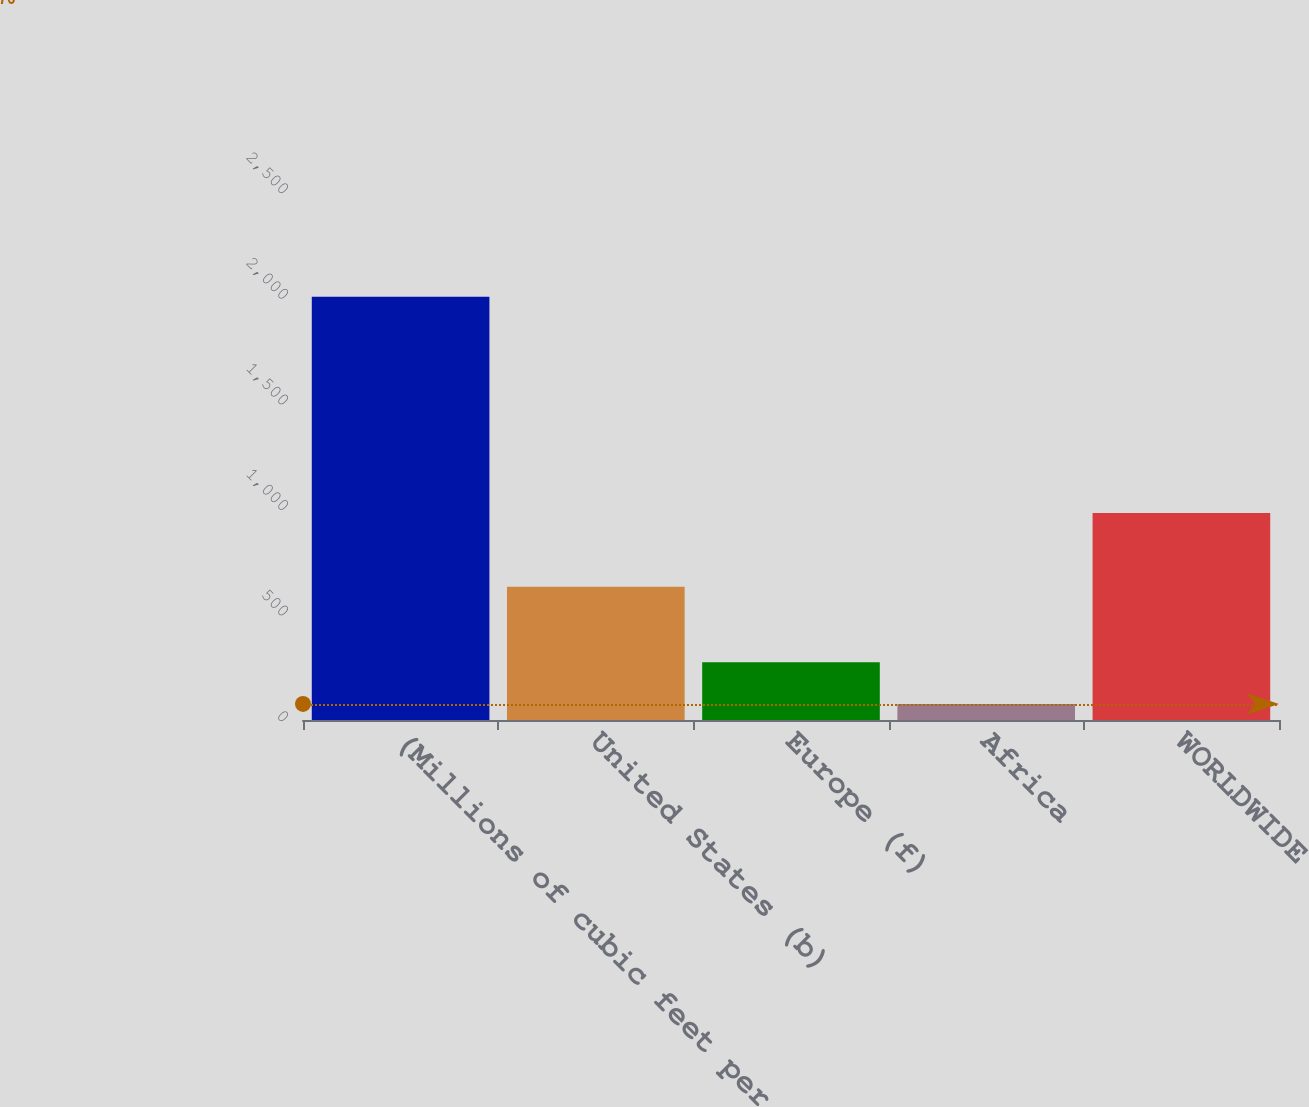Convert chart to OTSL. <chart><loc_0><loc_0><loc_500><loc_500><bar_chart><fcel>(Millions of cubic feet per<fcel>United States (b)<fcel>Europe (f)<fcel>Africa<fcel>WORLDWIDE<nl><fcel>2004<fcel>631<fcel>273<fcel>76<fcel>980<nl></chart> 